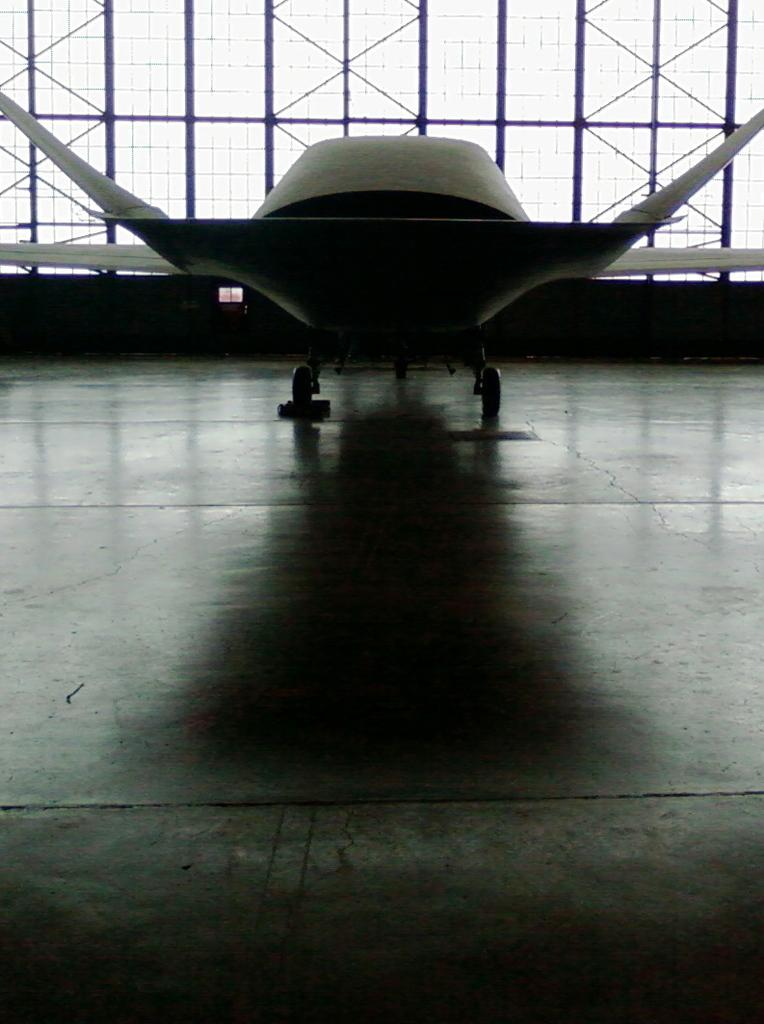What can be seen in the background of the image? There is an airplane in the background of the image. What feature is present in the image that allows for visibility? There are windows visible in the image. What type of corn is displayed on the calendar in the image? There is no corn or calendar present in the image. What view can be seen from the windows in the image? The view from the windows cannot be determined from the image alone, as the contents of the windows are not visible. 